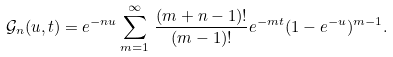Convert formula to latex. <formula><loc_0><loc_0><loc_500><loc_500>\mathcal { G } _ { n } ( u , t ) & = e ^ { - n u } \sum _ { m = 1 } ^ { \infty } \, \frac { ( m + n - 1 ) ! } { ( m - 1 ) ! } e ^ { - m t } ( 1 - e ^ { - u } ) ^ { m - 1 } .</formula> 